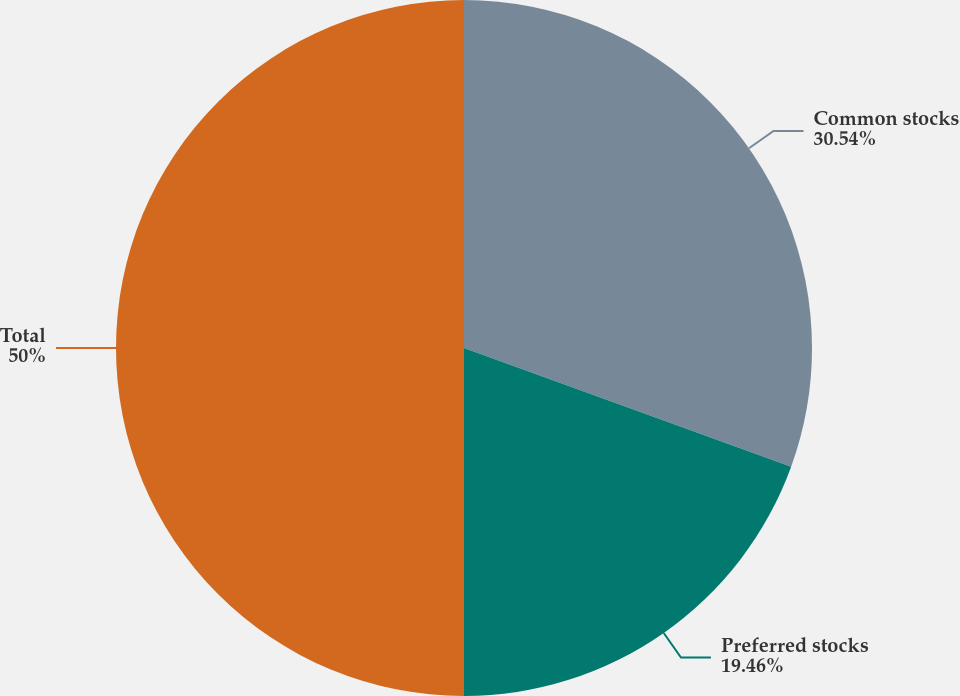Convert chart to OTSL. <chart><loc_0><loc_0><loc_500><loc_500><pie_chart><fcel>Common stocks<fcel>Preferred stocks<fcel>Total<nl><fcel>30.54%<fcel>19.46%<fcel>50.0%<nl></chart> 